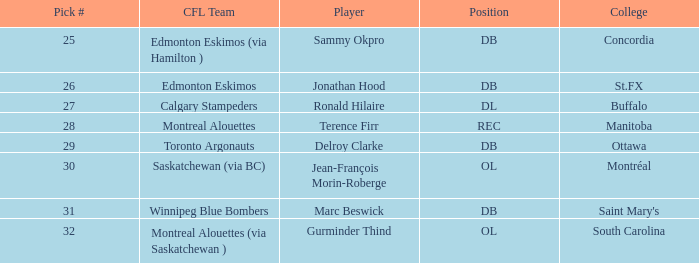Can you parse all the data within this table? {'header': ['Pick #', 'CFL Team', 'Player', 'Position', 'College'], 'rows': [['25', 'Edmonton Eskimos (via Hamilton )', 'Sammy Okpro', 'DB', 'Concordia'], ['26', 'Edmonton Eskimos', 'Jonathan Hood', 'DB', 'St.FX'], ['27', 'Calgary Stampeders', 'Ronald Hilaire', 'DL', 'Buffalo'], ['28', 'Montreal Alouettes', 'Terence Firr', 'REC', 'Manitoba'], ['29', 'Toronto Argonauts', 'Delroy Clarke', 'DB', 'Ottawa'], ['30', 'Saskatchewan (via BC)', 'Jean-François Morin-Roberge', 'OL', 'Montréal'], ['31', 'Winnipeg Blue Bombers', 'Marc Beswick', 'DB', "Saint Mary's"], ['32', 'Montreal Alouettes (via Saskatchewan )', 'Gurminder Thind', 'OL', 'South Carolina']]} Which college possesses an ol spot and a choice number below 32? Montréal. 